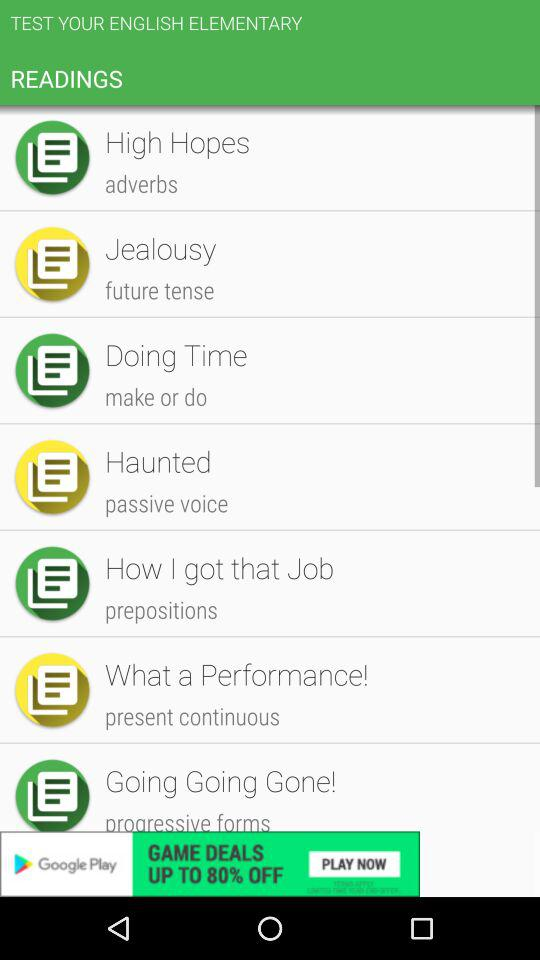Write a sentence of future tense?
When the provided information is insufficient, respond with <no answer>. <no answer> 